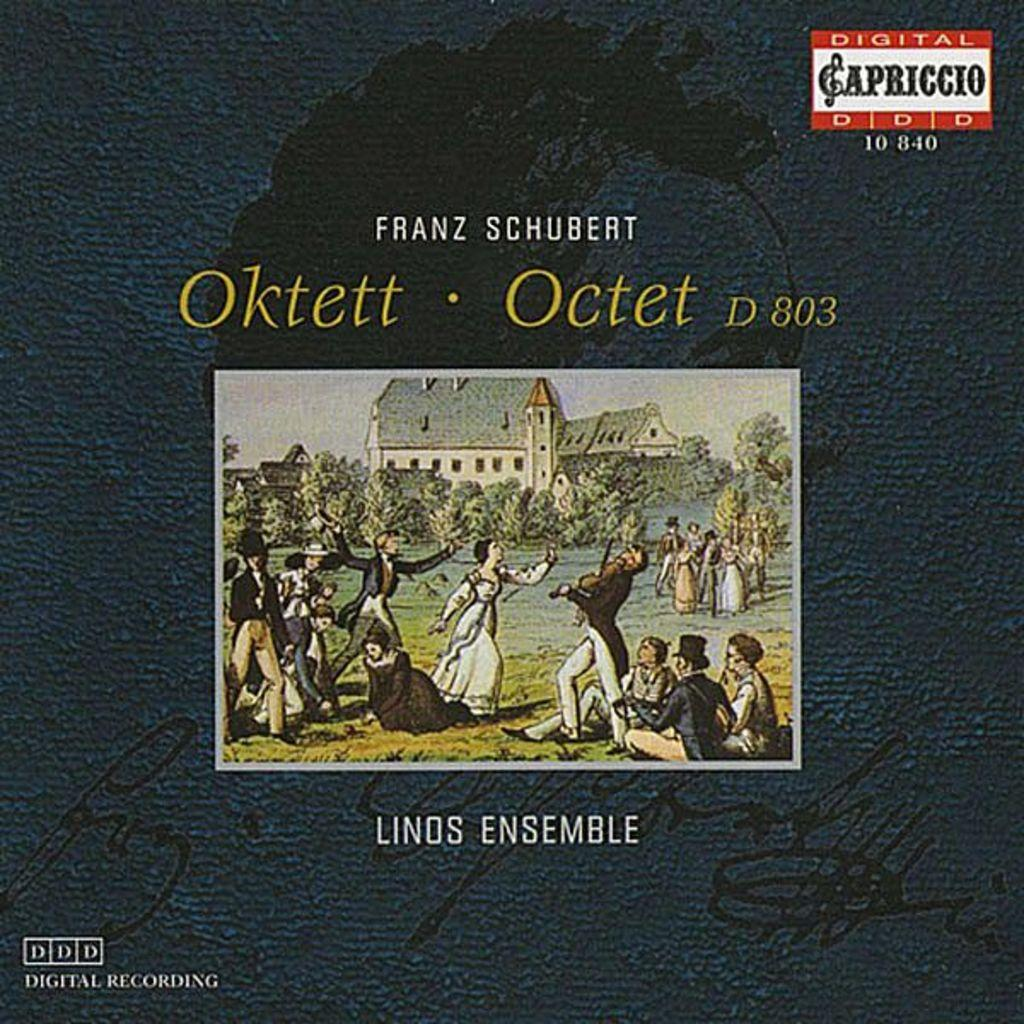<image>
Summarize the visual content of the image. A Digital Recording of Franz Schubert Oktett in Linds Ensemble. 